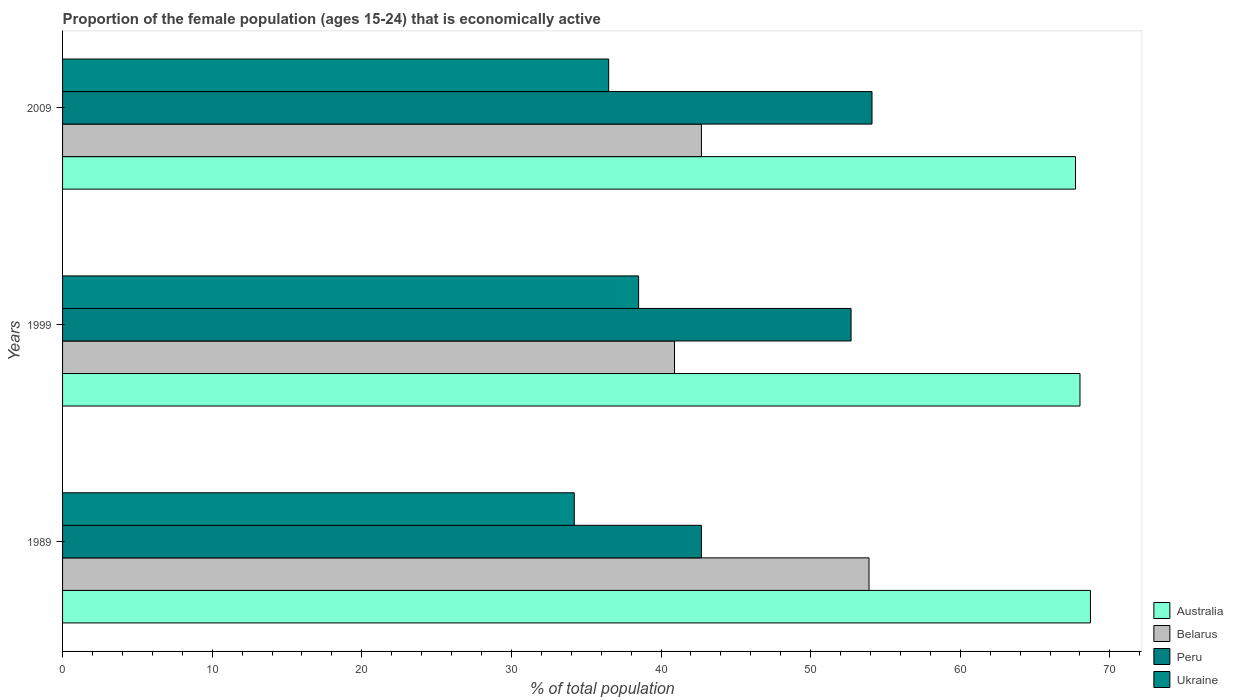How many different coloured bars are there?
Ensure brevity in your answer.  4. How many groups of bars are there?
Ensure brevity in your answer.  3. Are the number of bars per tick equal to the number of legend labels?
Keep it short and to the point. Yes. What is the proportion of the female population that is economically active in Ukraine in 1999?
Your answer should be compact. 38.5. Across all years, what is the maximum proportion of the female population that is economically active in Peru?
Your answer should be compact. 54.1. Across all years, what is the minimum proportion of the female population that is economically active in Peru?
Give a very brief answer. 42.7. In which year was the proportion of the female population that is economically active in Ukraine maximum?
Keep it short and to the point. 1999. What is the total proportion of the female population that is economically active in Belarus in the graph?
Offer a very short reply. 137.5. What is the difference between the proportion of the female population that is economically active in Peru in 1999 and that in 2009?
Your response must be concise. -1.4. What is the difference between the proportion of the female population that is economically active in Belarus in 1989 and the proportion of the female population that is economically active in Ukraine in 1999?
Provide a short and direct response. 15.4. What is the average proportion of the female population that is economically active in Ukraine per year?
Offer a terse response. 36.4. In the year 1989, what is the difference between the proportion of the female population that is economically active in Australia and proportion of the female population that is economically active in Ukraine?
Offer a very short reply. 34.5. What is the ratio of the proportion of the female population that is economically active in Australia in 1989 to that in 1999?
Your answer should be very brief. 1.01. What is the difference between the highest and the second highest proportion of the female population that is economically active in Peru?
Provide a succinct answer. 1.4. In how many years, is the proportion of the female population that is economically active in Australia greater than the average proportion of the female population that is economically active in Australia taken over all years?
Provide a succinct answer. 1. What does the 3rd bar from the top in 2009 represents?
Your answer should be compact. Belarus. What does the 3rd bar from the bottom in 1999 represents?
Offer a terse response. Peru. What is the difference between two consecutive major ticks on the X-axis?
Keep it short and to the point. 10. Does the graph contain any zero values?
Ensure brevity in your answer.  No. How many legend labels are there?
Your answer should be compact. 4. What is the title of the graph?
Your response must be concise. Proportion of the female population (ages 15-24) that is economically active. Does "Rwanda" appear as one of the legend labels in the graph?
Provide a short and direct response. No. What is the label or title of the X-axis?
Provide a short and direct response. % of total population. What is the % of total population in Australia in 1989?
Your response must be concise. 68.7. What is the % of total population of Belarus in 1989?
Ensure brevity in your answer.  53.9. What is the % of total population in Peru in 1989?
Offer a very short reply. 42.7. What is the % of total population of Ukraine in 1989?
Provide a short and direct response. 34.2. What is the % of total population in Australia in 1999?
Provide a succinct answer. 68. What is the % of total population in Belarus in 1999?
Offer a terse response. 40.9. What is the % of total population of Peru in 1999?
Your answer should be very brief. 52.7. What is the % of total population of Ukraine in 1999?
Make the answer very short. 38.5. What is the % of total population of Australia in 2009?
Your response must be concise. 67.7. What is the % of total population in Belarus in 2009?
Make the answer very short. 42.7. What is the % of total population in Peru in 2009?
Ensure brevity in your answer.  54.1. What is the % of total population in Ukraine in 2009?
Your response must be concise. 36.5. Across all years, what is the maximum % of total population in Australia?
Provide a short and direct response. 68.7. Across all years, what is the maximum % of total population of Belarus?
Make the answer very short. 53.9. Across all years, what is the maximum % of total population in Peru?
Ensure brevity in your answer.  54.1. Across all years, what is the maximum % of total population in Ukraine?
Ensure brevity in your answer.  38.5. Across all years, what is the minimum % of total population of Australia?
Your response must be concise. 67.7. Across all years, what is the minimum % of total population of Belarus?
Give a very brief answer. 40.9. Across all years, what is the minimum % of total population of Peru?
Provide a succinct answer. 42.7. Across all years, what is the minimum % of total population in Ukraine?
Keep it short and to the point. 34.2. What is the total % of total population in Australia in the graph?
Your answer should be compact. 204.4. What is the total % of total population of Belarus in the graph?
Offer a very short reply. 137.5. What is the total % of total population in Peru in the graph?
Your response must be concise. 149.5. What is the total % of total population of Ukraine in the graph?
Make the answer very short. 109.2. What is the difference between the % of total population of Australia in 1989 and that in 1999?
Make the answer very short. 0.7. What is the difference between the % of total population in Belarus in 1989 and that in 1999?
Your response must be concise. 13. What is the difference between the % of total population of Australia in 1989 and that in 2009?
Provide a succinct answer. 1. What is the difference between the % of total population in Belarus in 1989 and that in 2009?
Make the answer very short. 11.2. What is the difference between the % of total population in Belarus in 1999 and that in 2009?
Give a very brief answer. -1.8. What is the difference between the % of total population in Australia in 1989 and the % of total population in Belarus in 1999?
Offer a very short reply. 27.8. What is the difference between the % of total population in Australia in 1989 and the % of total population in Ukraine in 1999?
Ensure brevity in your answer.  30.2. What is the difference between the % of total population in Belarus in 1989 and the % of total population in Ukraine in 1999?
Give a very brief answer. 15.4. What is the difference between the % of total population in Australia in 1989 and the % of total population in Peru in 2009?
Your answer should be very brief. 14.6. What is the difference between the % of total population of Australia in 1989 and the % of total population of Ukraine in 2009?
Provide a short and direct response. 32.2. What is the difference between the % of total population in Australia in 1999 and the % of total population in Belarus in 2009?
Give a very brief answer. 25.3. What is the difference between the % of total population in Australia in 1999 and the % of total population in Peru in 2009?
Offer a terse response. 13.9. What is the difference between the % of total population of Australia in 1999 and the % of total population of Ukraine in 2009?
Give a very brief answer. 31.5. What is the difference between the % of total population in Belarus in 1999 and the % of total population in Ukraine in 2009?
Keep it short and to the point. 4.4. What is the average % of total population of Australia per year?
Keep it short and to the point. 68.13. What is the average % of total population of Belarus per year?
Offer a very short reply. 45.83. What is the average % of total population of Peru per year?
Ensure brevity in your answer.  49.83. What is the average % of total population in Ukraine per year?
Give a very brief answer. 36.4. In the year 1989, what is the difference between the % of total population in Australia and % of total population in Belarus?
Provide a short and direct response. 14.8. In the year 1989, what is the difference between the % of total population in Australia and % of total population in Peru?
Keep it short and to the point. 26. In the year 1989, what is the difference between the % of total population in Australia and % of total population in Ukraine?
Ensure brevity in your answer.  34.5. In the year 1989, what is the difference between the % of total population in Belarus and % of total population in Peru?
Your answer should be very brief. 11.2. In the year 1989, what is the difference between the % of total population of Peru and % of total population of Ukraine?
Ensure brevity in your answer.  8.5. In the year 1999, what is the difference between the % of total population of Australia and % of total population of Belarus?
Offer a very short reply. 27.1. In the year 1999, what is the difference between the % of total population in Australia and % of total population in Peru?
Provide a succinct answer. 15.3. In the year 1999, what is the difference between the % of total population of Australia and % of total population of Ukraine?
Your answer should be compact. 29.5. In the year 1999, what is the difference between the % of total population in Belarus and % of total population in Ukraine?
Your answer should be very brief. 2.4. In the year 2009, what is the difference between the % of total population in Australia and % of total population in Belarus?
Offer a very short reply. 25. In the year 2009, what is the difference between the % of total population in Australia and % of total population in Ukraine?
Provide a succinct answer. 31.2. In the year 2009, what is the difference between the % of total population in Peru and % of total population in Ukraine?
Give a very brief answer. 17.6. What is the ratio of the % of total population of Australia in 1989 to that in 1999?
Your response must be concise. 1.01. What is the ratio of the % of total population in Belarus in 1989 to that in 1999?
Give a very brief answer. 1.32. What is the ratio of the % of total population of Peru in 1989 to that in 1999?
Offer a terse response. 0.81. What is the ratio of the % of total population in Ukraine in 1989 to that in 1999?
Make the answer very short. 0.89. What is the ratio of the % of total population in Australia in 1989 to that in 2009?
Keep it short and to the point. 1.01. What is the ratio of the % of total population of Belarus in 1989 to that in 2009?
Keep it short and to the point. 1.26. What is the ratio of the % of total population in Peru in 1989 to that in 2009?
Provide a short and direct response. 0.79. What is the ratio of the % of total population in Ukraine in 1989 to that in 2009?
Your answer should be very brief. 0.94. What is the ratio of the % of total population in Belarus in 1999 to that in 2009?
Make the answer very short. 0.96. What is the ratio of the % of total population of Peru in 1999 to that in 2009?
Give a very brief answer. 0.97. What is the ratio of the % of total population in Ukraine in 1999 to that in 2009?
Offer a very short reply. 1.05. What is the difference between the highest and the second highest % of total population in Australia?
Keep it short and to the point. 0.7. What is the difference between the highest and the second highest % of total population of Peru?
Ensure brevity in your answer.  1.4. What is the difference between the highest and the second highest % of total population in Ukraine?
Provide a short and direct response. 2. What is the difference between the highest and the lowest % of total population in Australia?
Your response must be concise. 1. What is the difference between the highest and the lowest % of total population in Belarus?
Make the answer very short. 13. What is the difference between the highest and the lowest % of total population in Peru?
Your answer should be very brief. 11.4. What is the difference between the highest and the lowest % of total population of Ukraine?
Offer a terse response. 4.3. 